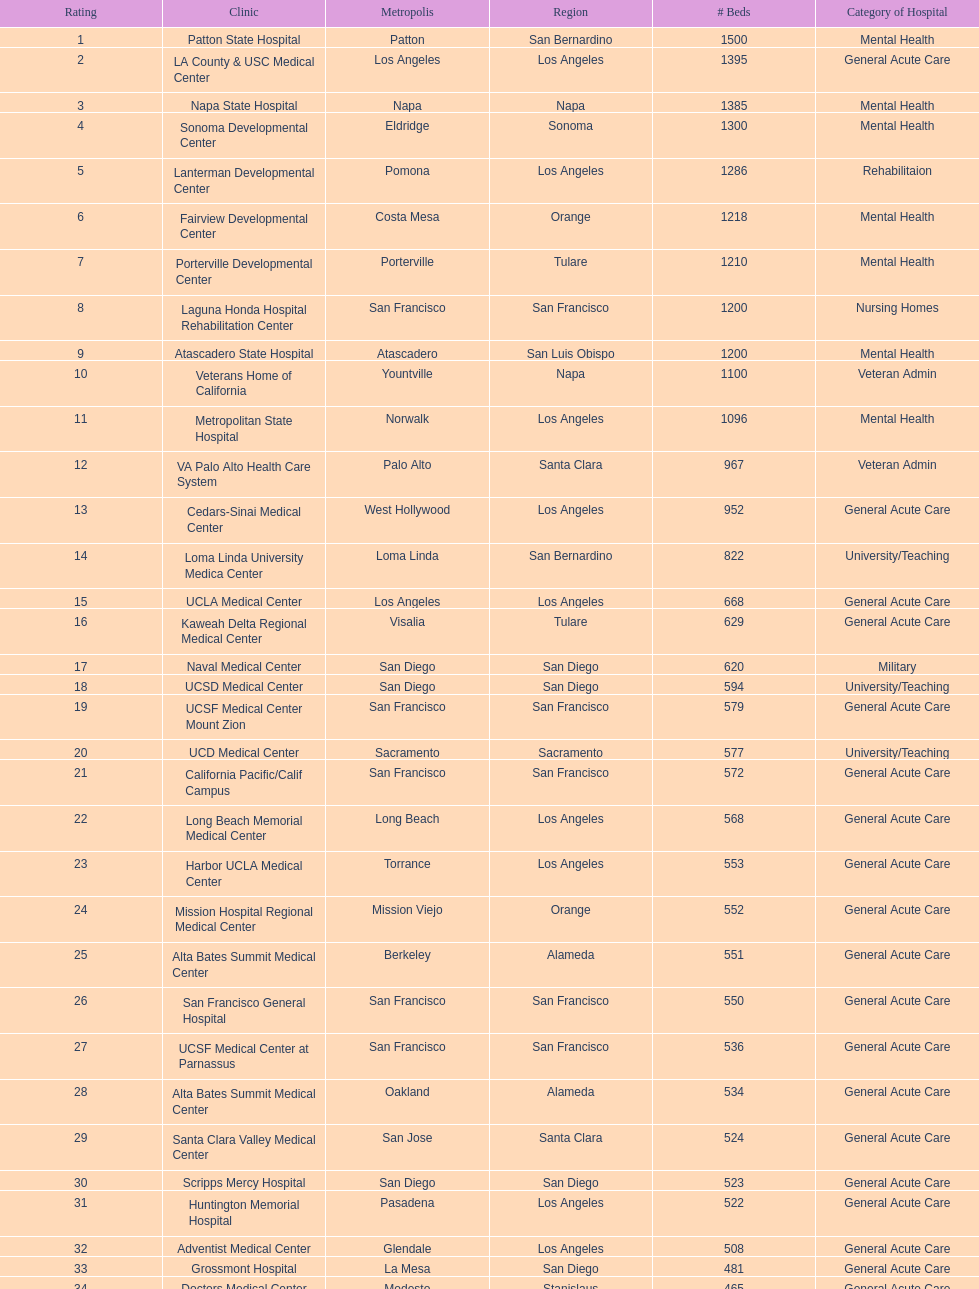How many more general acute care hospitals are there in california than rehabilitation hospitals? 33. 